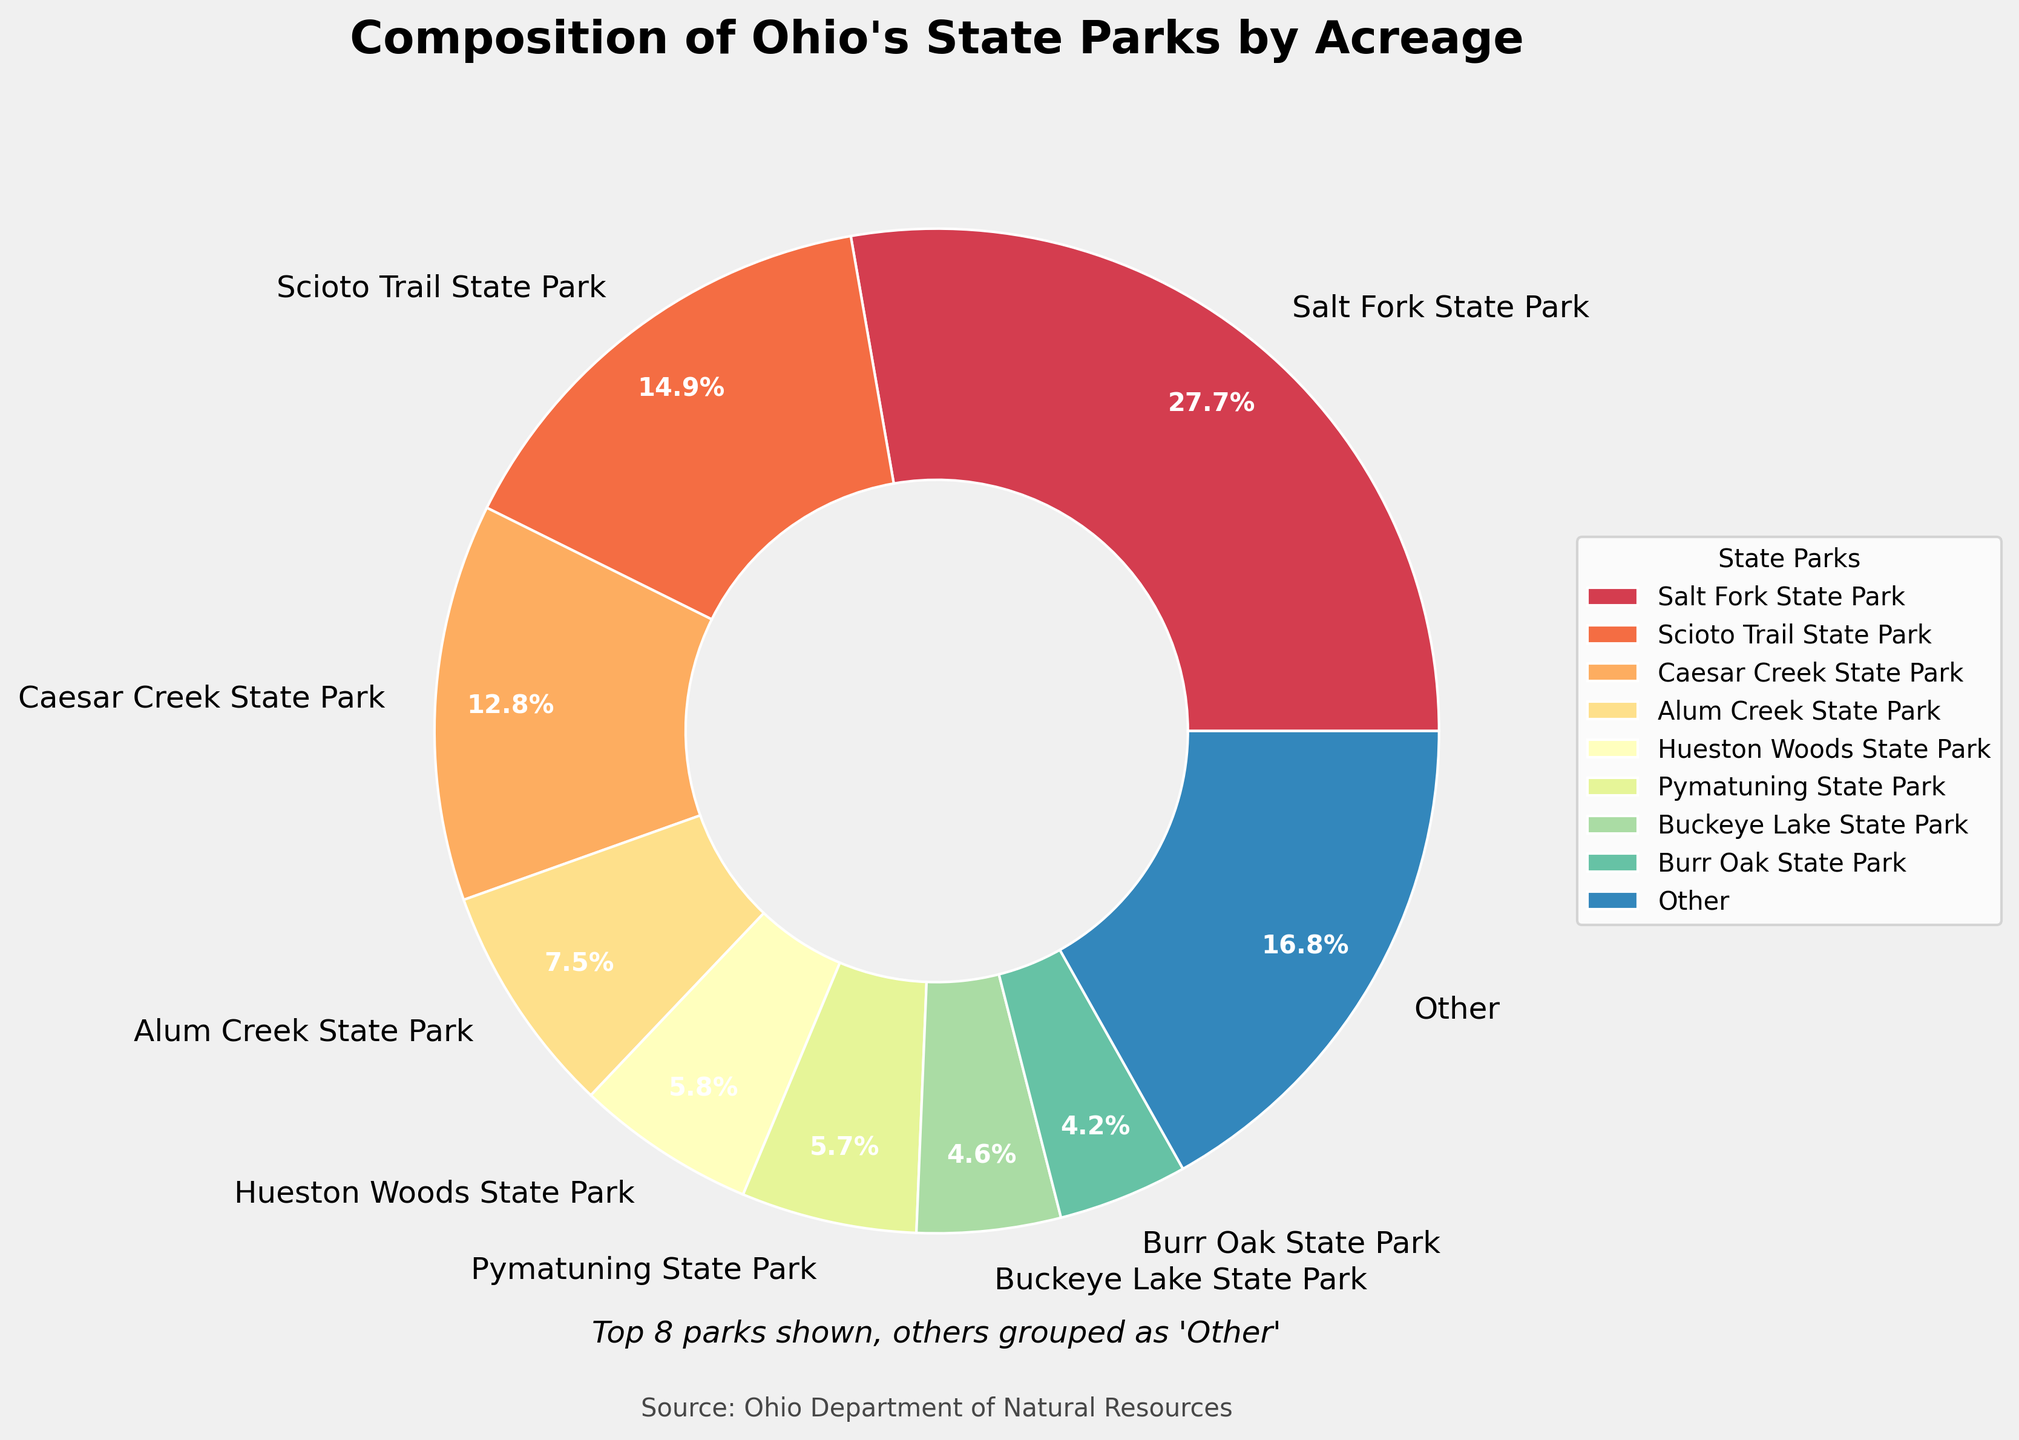What is the largest park by acreage? The largest slice in the pie chart represents Salt Fork State Park, so it is the largest by acreage.
Answer: Salt Fork State Park Which park has the smallest acreage in the 'Top 8 parks'? In the pie chart, among the labeled parks, Maumee Bay State Park has the smallest percentage slice.
Answer: Maumee Bay State Park What percentage of the total acreage do the 'Other' parks represent? The pie chart includes a slice labeled 'Other'. According to the chart, 'Other' parks make up 28.3% of the total acreage.
Answer: 28.3% How many parks are grouped under 'Other'? Given that the top 8 parks are listed individually, all remaining parks are grouped under 'Other'. The figure does not specify how many parks are part of 'Other', so this question cannot be accurately answered just by looking at the pie chart.
Answer: Not answerable What is the combined percentage of Salt Fork State Park and Scioto Trail State Park? The pie chart shows that Salt Fork State Park accounts for 22.8% and Scioto Trail State Park accounts for 12.3% of the total acreage. Adding their percentages gives 35.1%.
Answer: 35.1% Which park appears closest to the halfway mark (in terms of percentage) among the top 8 parks? The halfway mark, 50%, would presumably be close to the combined sections of several parks. Looking at the pie chart, Deer Creek State Park’s 3.1% mark is the midpoint of the eighth section labeled individually before moving to the 'Other' section.
Answer: Deer Creek State Park Which park has about half the acreage of Caesar Creek State Park? Caesar Creek State Park represents 10.5%, and Hueston Woods State Park represents 4.8% in the pie chart. Half of 10.5% is 5.25%, making Hueston Woods State Park the closest.
Answer: Hueston Woods State Park How does the acreage of Maumee Bay State Park compare to that of Pymatuning State Park? The pie chart shows Maumee Bay State Park at 1.8% and Pymatuning State Park at 4.6%. Pymatuning State Park has a larger acreage.
Answer: Pymatuning State Park has more What is the approximate difference in acreage percentage between the largest and smallest park in the 'Top 8 parks'? The largest park in the 'Top 8 parks' is Salt Fork State Park with 22.8%, and the smallest is Maumee Bay State Park with 1.8%. The difference is 22.8% - 1.8% = 21%.
Answer: 21% What is the median percentage of the top 8 parks by acreage? The percentages of the top 8 parks, in descending order, are 22.8%, 12.3%, 10.5%, 8.3%, 6.3%, 5.9%, 4.8%, and 3.1%. The median would be the average of the 4th and 5th values, (8.3% + 6.3%) / 2 = 7.3%.
Answer: 7.3% 